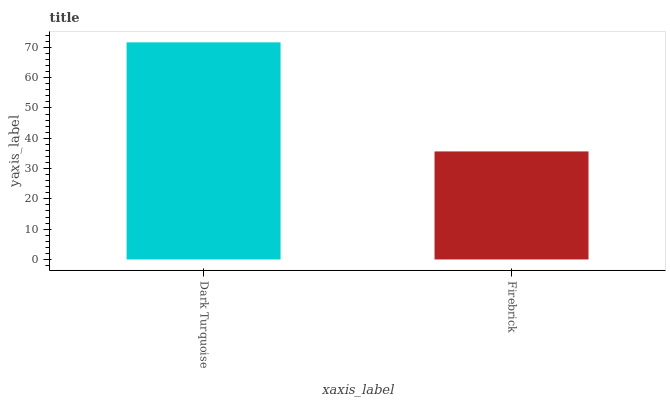Is Firebrick the minimum?
Answer yes or no. Yes. Is Dark Turquoise the maximum?
Answer yes or no. Yes. Is Firebrick the maximum?
Answer yes or no. No. Is Dark Turquoise greater than Firebrick?
Answer yes or no. Yes. Is Firebrick less than Dark Turquoise?
Answer yes or no. Yes. Is Firebrick greater than Dark Turquoise?
Answer yes or no. No. Is Dark Turquoise less than Firebrick?
Answer yes or no. No. Is Dark Turquoise the high median?
Answer yes or no. Yes. Is Firebrick the low median?
Answer yes or no. Yes. Is Firebrick the high median?
Answer yes or no. No. Is Dark Turquoise the low median?
Answer yes or no. No. 